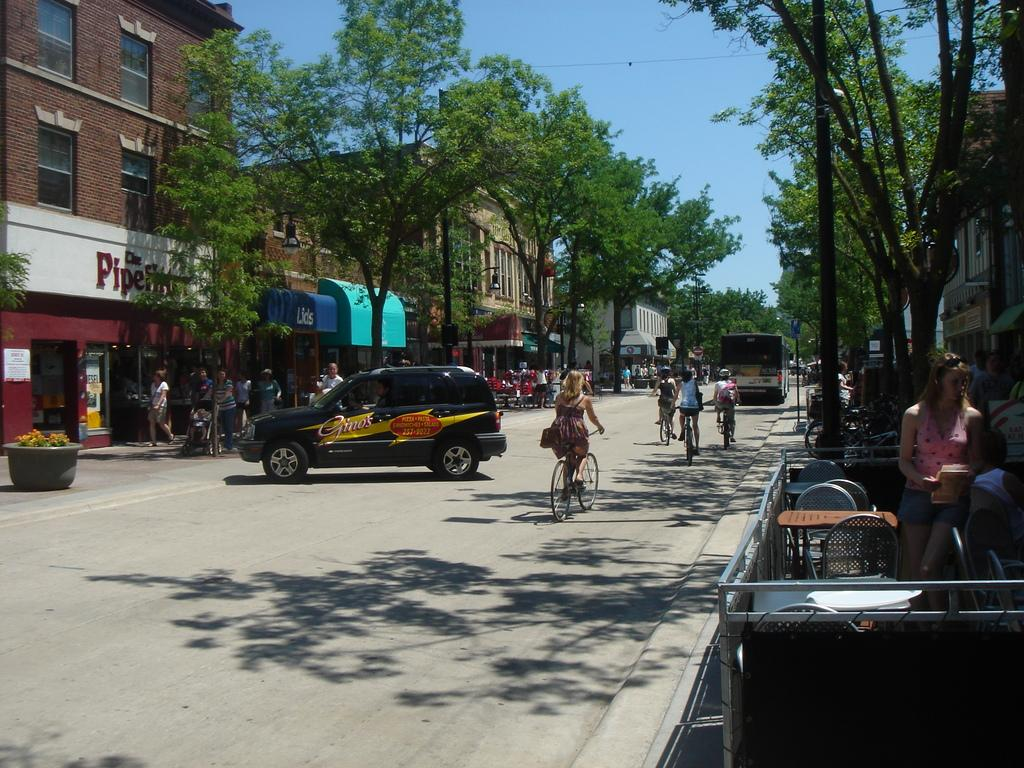<image>
Relay a brief, clear account of the picture shown. An SUV from Gino's pizza shop is parked sideways in the street. 